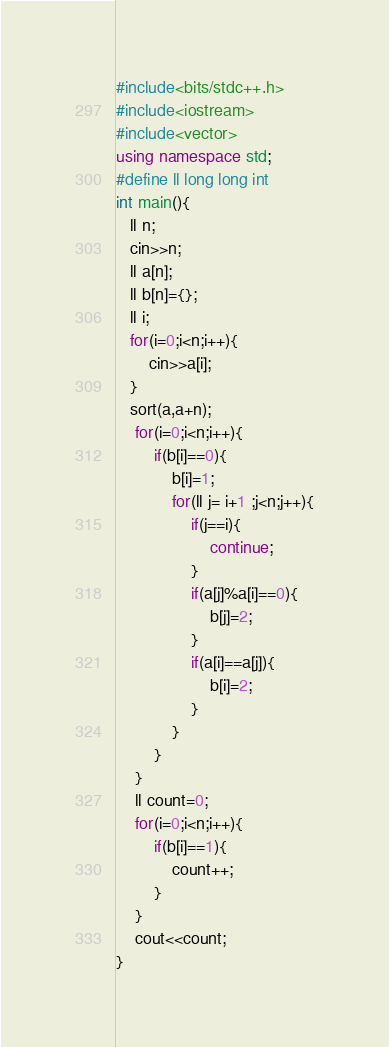<code> <loc_0><loc_0><loc_500><loc_500><_C++_>#include<bits/stdc++.h>
#include<iostream>
#include<vector>
using namespace std;
#define ll long long int
int main(){
   ll n;
   cin>>n;
   ll a[n];
   ll b[n]={};
   ll i;
   for(i=0;i<n;i++){
       cin>>a[i];
   }
   sort(a,a+n);
    for(i=0;i<n;i++){
        if(b[i]==0){
            b[i]=1;
            for(ll j= i+1 ;j<n;j++){
                if(j==i){
                    continue;
                }
                if(a[j]%a[i]==0){
                    b[j]=2;
                }
                if(a[i]==a[j]){
                    b[i]=2;
                }
            }
        }
    }
    ll count=0;
    for(i=0;i<n;i++){
        if(b[i]==1){
            count++;
        }
    }
    cout<<count;
}
</code> 